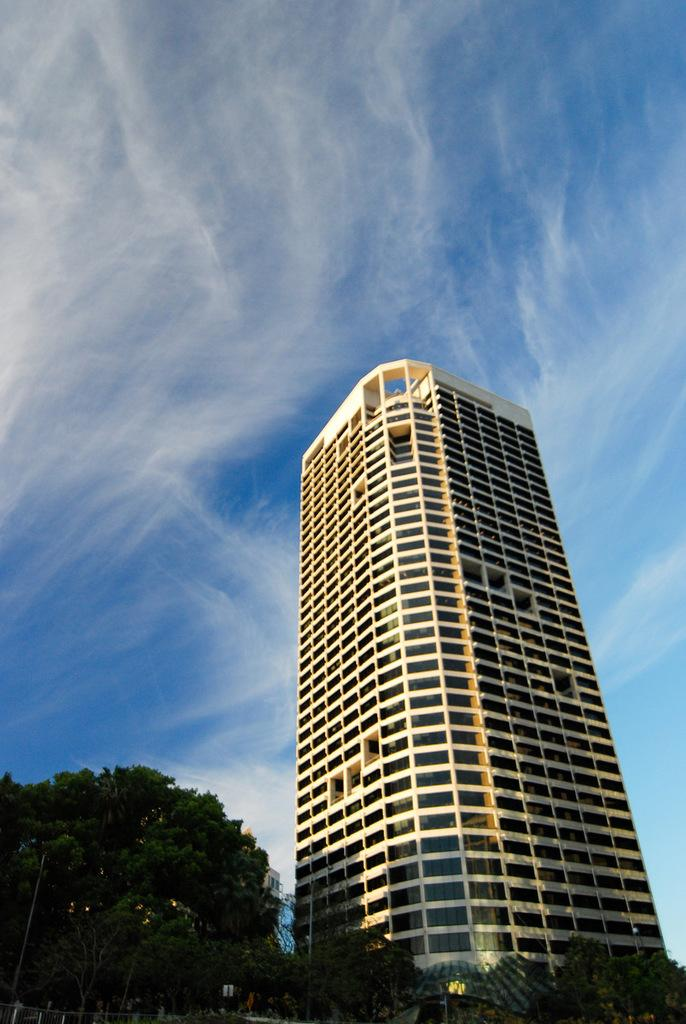What type of structure is present in the image? There is a building in the image. What other natural elements can be seen in the image? There are trees in the image. What is visible in the background of the image? The sky is visible in the background of the image. What type of knowledge can be gained from the light bulb in the image? There is no light bulb present in the image, so no knowledge can be gained from it. 